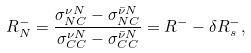Convert formula to latex. <formula><loc_0><loc_0><loc_500><loc_500>R ^ { - } _ { N } = \frac { \sigma ^ { \nu N } _ { N C } - \sigma ^ { \bar { \nu } N } _ { N C } } { \sigma ^ { \nu N } _ { C C } - \sigma ^ { \bar { \nu } N } _ { C C } } = R ^ { - } - \delta R ^ { - } _ { s } ,</formula> 